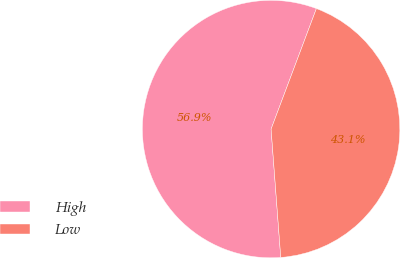Convert chart. <chart><loc_0><loc_0><loc_500><loc_500><pie_chart><fcel>High<fcel>Low<nl><fcel>56.92%<fcel>43.08%<nl></chart> 